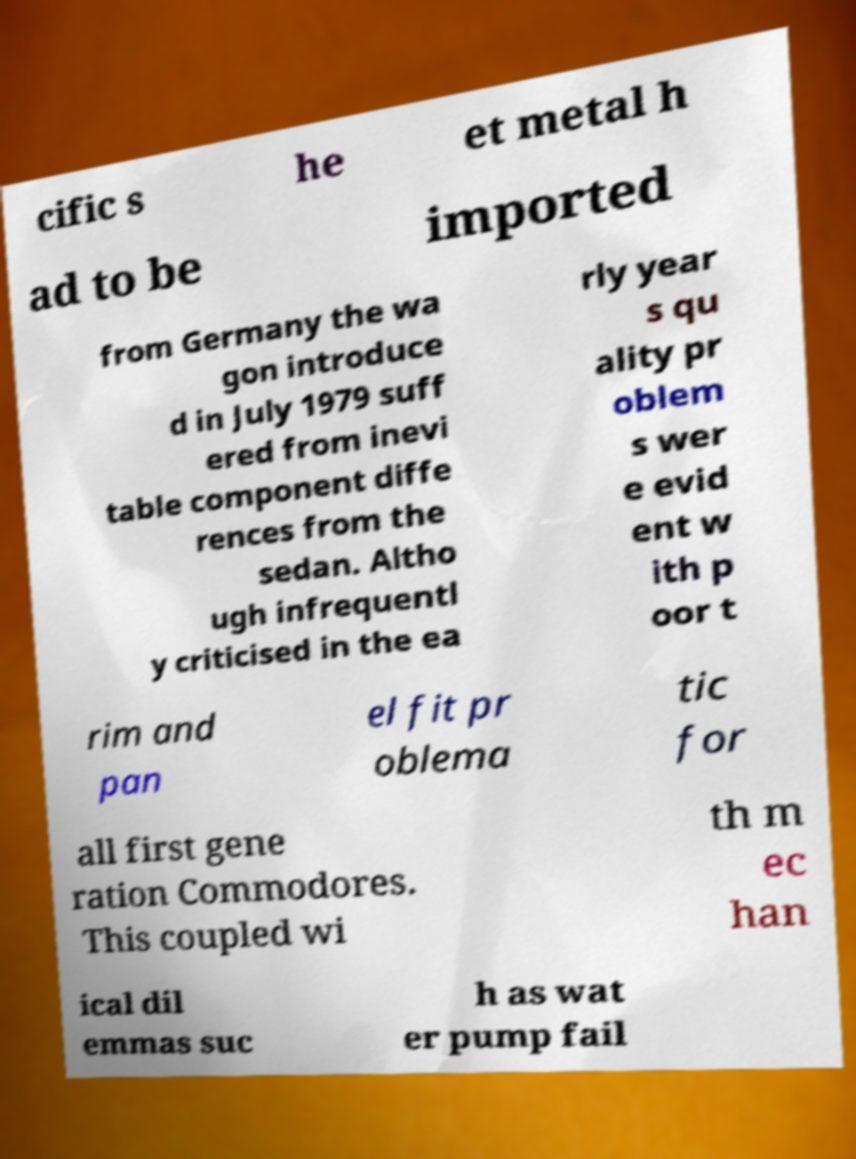Can you accurately transcribe the text from the provided image for me? cific s he et metal h ad to be imported from Germany the wa gon introduce d in July 1979 suff ered from inevi table component diffe rences from the sedan. Altho ugh infrequentl y criticised in the ea rly year s qu ality pr oblem s wer e evid ent w ith p oor t rim and pan el fit pr oblema tic for all first gene ration Commodores. This coupled wi th m ec han ical dil emmas suc h as wat er pump fail 